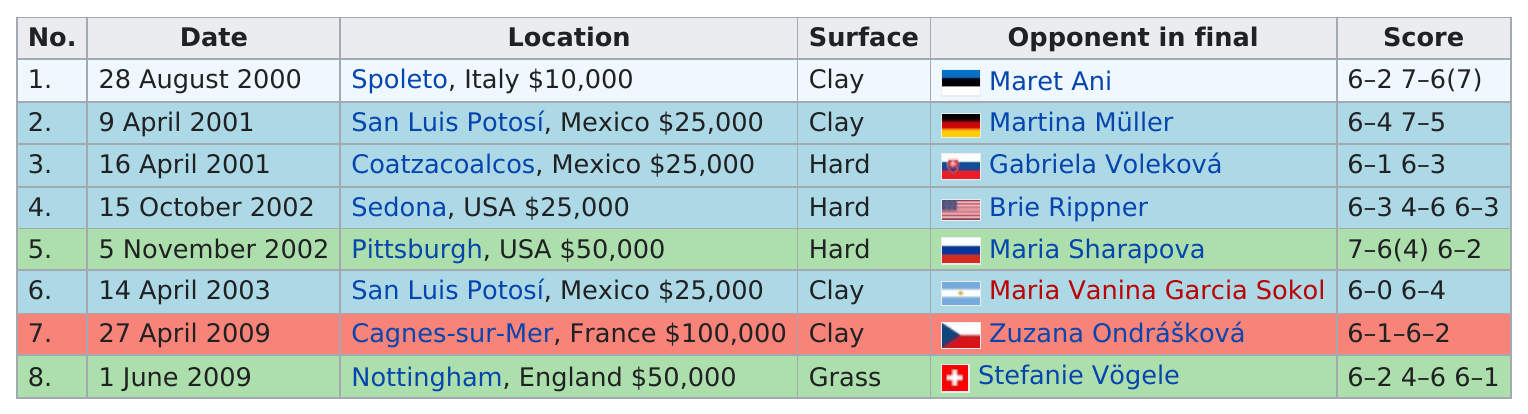List a handful of essential elements in this visual. Camrin won $40,000 more money in Pittsburgh than in Spoleto," the report declared. There are a total of three locations that are situated above Sedona. The total number of locations that utilized clay surfaces is 4. Camerin won the singles match on a court that was not clay or grass, it was a hard court. Out of the total number of matches that were not played on a clay surface, 4 matches were not played on a clay surface. 